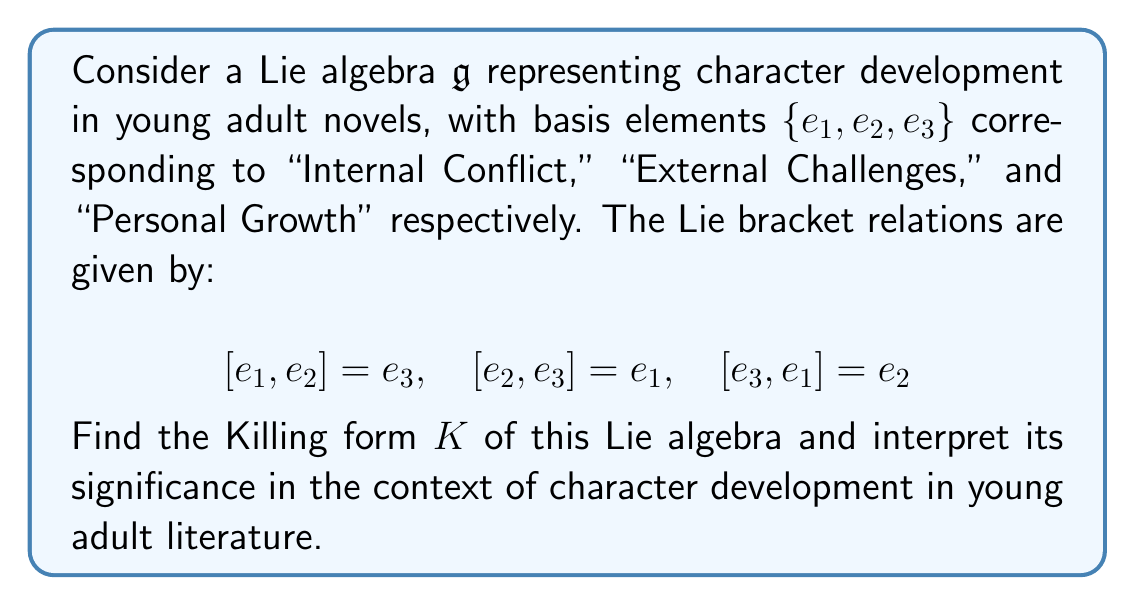Solve this math problem. To find the Killing form of the given Lie algebra, we follow these steps:

1) The Killing form $K(X,Y)$ is defined as $K(X,Y) = \text{tr}(\text{ad}_X \circ \text{ad}_Y)$, where $\text{ad}_X$ is the adjoint representation of $X$.

2) First, we need to find the matrix representations of $\text{ad}_{e_1}$, $\text{ad}_{e_2}$, and $\text{ad}_{e_3}$:

   $\text{ad}_{e_1} = \begin{pmatrix} 0 & 0 & -1 \\ 0 & 0 & 0 \\ 0 & 1 & 0 \end{pmatrix}$

   $\text{ad}_{e_2} = \begin{pmatrix} 0 & 0 & 0 \\ 0 & 0 & -1 \\ 1 & 0 & 0 \end{pmatrix}$

   $\text{ad}_{e_3} = \begin{pmatrix} 0 & -1 & 0 \\ 1 & 0 & 0 \\ 0 & 0 & 0 \end{pmatrix}$

3) Now, we calculate $K(e_i, e_j)$ for all pairs $i,j \in \{1,2,3\}$:

   $K(e_1, e_1) = \text{tr}(\text{ad}_{e_1} \circ \text{ad}_{e_1}) = -2$
   $K(e_2, e_2) = \text{tr}(\text{ad}_{e_2} \circ \text{ad}_{e_2}) = -2$
   $K(e_3, e_3) = \text{tr}(\text{ad}_{e_3} \circ \text{ad}_{e_3}) = -2$
   $K(e_1, e_2) = K(e_2, e_1) = \text{tr}(\text{ad}_{e_1} \circ \text{ad}_{e_2}) = 0$
   $K(e_1, e_3) = K(e_3, e_1) = \text{tr}(\text{ad}_{e_1} \circ \text{ad}_{e_3}) = 0$
   $K(e_2, e_3) = K(e_3, e_2) = \text{tr}(\text{ad}_{e_2} \circ \text{ad}_{e_3}) = 0$

4) Therefore, the Killing form can be represented as the matrix:

   $K = \begin{pmatrix} -2 & 0 & 0 \\ 0 & -2 & 0 \\ 0 & 0 & -2 \end{pmatrix}$

Interpretation in the context of young adult literature:
The Killing form reveals that the three aspects of character development (Internal Conflict, External Challenges, and Personal Growth) are equally important and interconnected in young adult novels. The diagonal entries being equal and non-zero indicate that each aspect has equal weight in character development. The off-diagonal entries being zero suggest that while these aspects interact through the Lie bracket (as seen in the original relations), they maintain distinct roles in shaping a character's journey.
Answer: The Killing form of the given Lie algebra is:

$$K = \begin{pmatrix} -2 & 0 & 0 \\ 0 & -2 & 0 \\ 0 & 0 & -2 \end{pmatrix}$$

This form indicates equal importance and distinct roles of Internal Conflict, External Challenges, and Personal Growth in character development within young adult literature. 